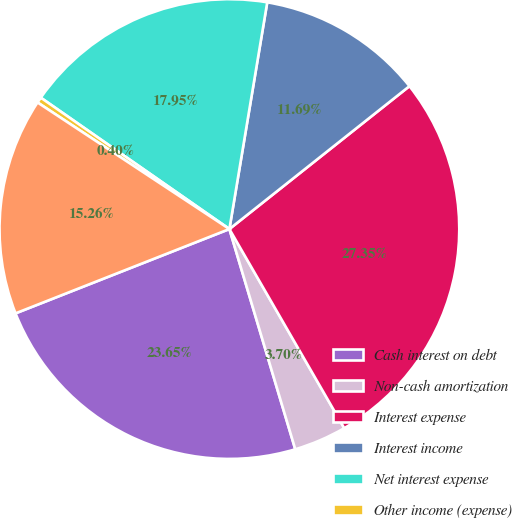<chart> <loc_0><loc_0><loc_500><loc_500><pie_chart><fcel>Cash interest on debt<fcel>Non-cash amortization<fcel>Interest expense<fcel>Interest income<fcel>Net interest expense<fcel>Other income (expense)<fcel>Total<nl><fcel>23.65%<fcel>3.7%<fcel>27.35%<fcel>11.69%<fcel>17.95%<fcel>0.4%<fcel>15.26%<nl></chart> 